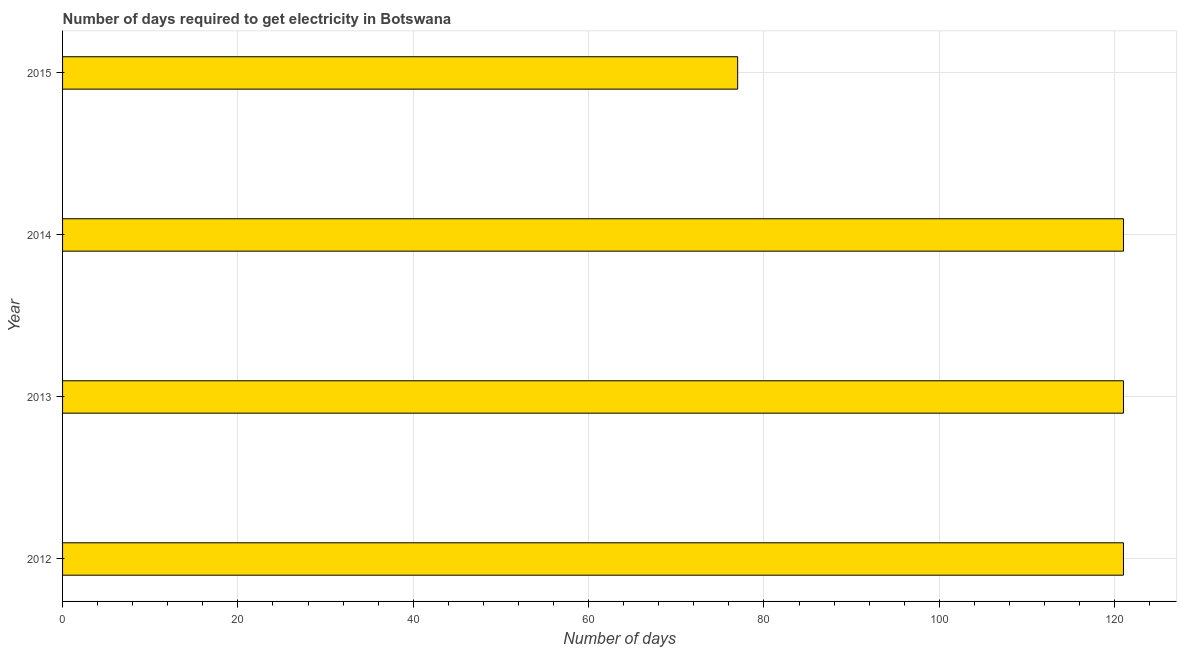Does the graph contain any zero values?
Ensure brevity in your answer.  No. Does the graph contain grids?
Offer a very short reply. Yes. What is the title of the graph?
Make the answer very short. Number of days required to get electricity in Botswana. What is the label or title of the X-axis?
Offer a terse response. Number of days. What is the time to get electricity in 2015?
Your response must be concise. 77. Across all years, what is the maximum time to get electricity?
Keep it short and to the point. 121. In which year was the time to get electricity maximum?
Provide a short and direct response. 2012. In which year was the time to get electricity minimum?
Keep it short and to the point. 2015. What is the sum of the time to get electricity?
Make the answer very short. 440. What is the average time to get electricity per year?
Make the answer very short. 110. What is the median time to get electricity?
Your response must be concise. 121. Do a majority of the years between 2015 and 2014 (inclusive) have time to get electricity greater than 60 ?
Provide a short and direct response. No. What is the difference between the highest and the second highest time to get electricity?
Your response must be concise. 0. What is the difference between the highest and the lowest time to get electricity?
Provide a succinct answer. 44. How many years are there in the graph?
Offer a very short reply. 4. What is the difference between two consecutive major ticks on the X-axis?
Provide a short and direct response. 20. What is the Number of days of 2012?
Your answer should be very brief. 121. What is the Number of days of 2013?
Make the answer very short. 121. What is the Number of days of 2014?
Provide a succinct answer. 121. What is the Number of days in 2015?
Offer a very short reply. 77. What is the difference between the Number of days in 2013 and 2014?
Offer a very short reply. 0. What is the difference between the Number of days in 2013 and 2015?
Provide a succinct answer. 44. What is the difference between the Number of days in 2014 and 2015?
Keep it short and to the point. 44. What is the ratio of the Number of days in 2012 to that in 2015?
Provide a succinct answer. 1.57. What is the ratio of the Number of days in 2013 to that in 2014?
Give a very brief answer. 1. What is the ratio of the Number of days in 2013 to that in 2015?
Give a very brief answer. 1.57. What is the ratio of the Number of days in 2014 to that in 2015?
Offer a terse response. 1.57. 